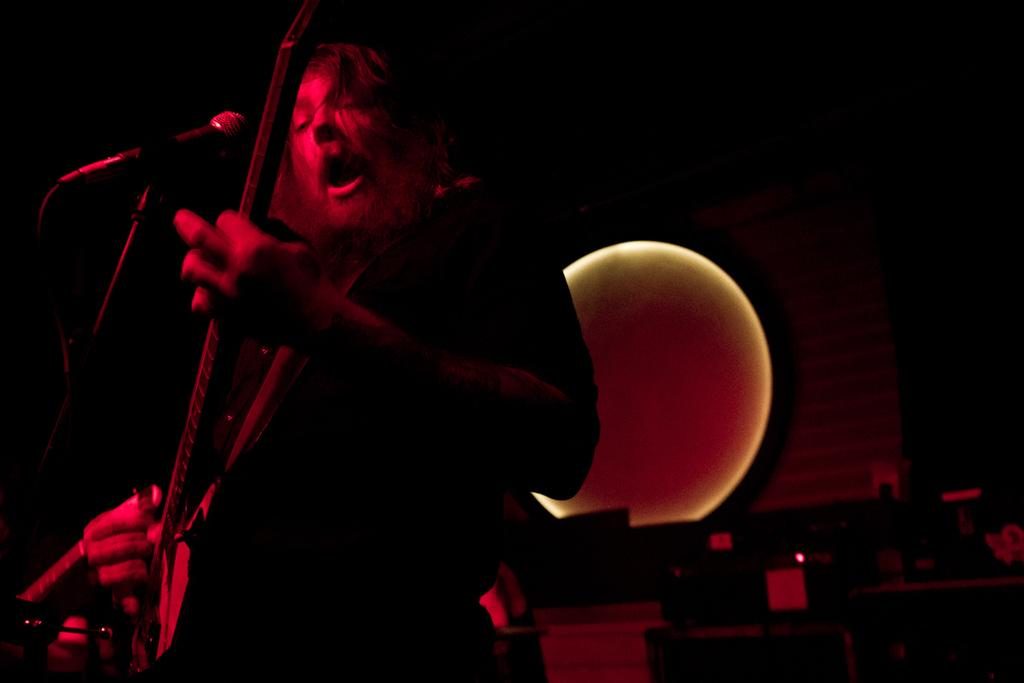Who is present in the image? There is a person in the image. What is the person doing in the image? The person is standing and holding a musical instrument. What object is visible in the image that is commonly used for amplifying sound? There is a microphone in the image. Where is the microphone placed in relation to the person? The microphone is placed in front of the person. What type of lock can be seen on the musical instrument in the image? There is no lock present on the musical instrument in the image. 